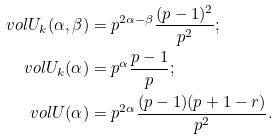Convert formula to latex. <formula><loc_0><loc_0><loc_500><loc_500>\ v o l U _ { k } ( \alpha , \beta ) & = p ^ { 2 \alpha - \beta } \frac { ( p - 1 ) ^ { 2 } } { p ^ { 2 } } ; \\ \ v o l U _ { k } ( \alpha ) & = p ^ { \alpha } \frac { p - 1 } p ; \\ \ v o l U ( \alpha ) & = p ^ { 2 \alpha } \frac { ( p - 1 ) ( p + 1 - r ) } { p ^ { 2 } } .</formula> 